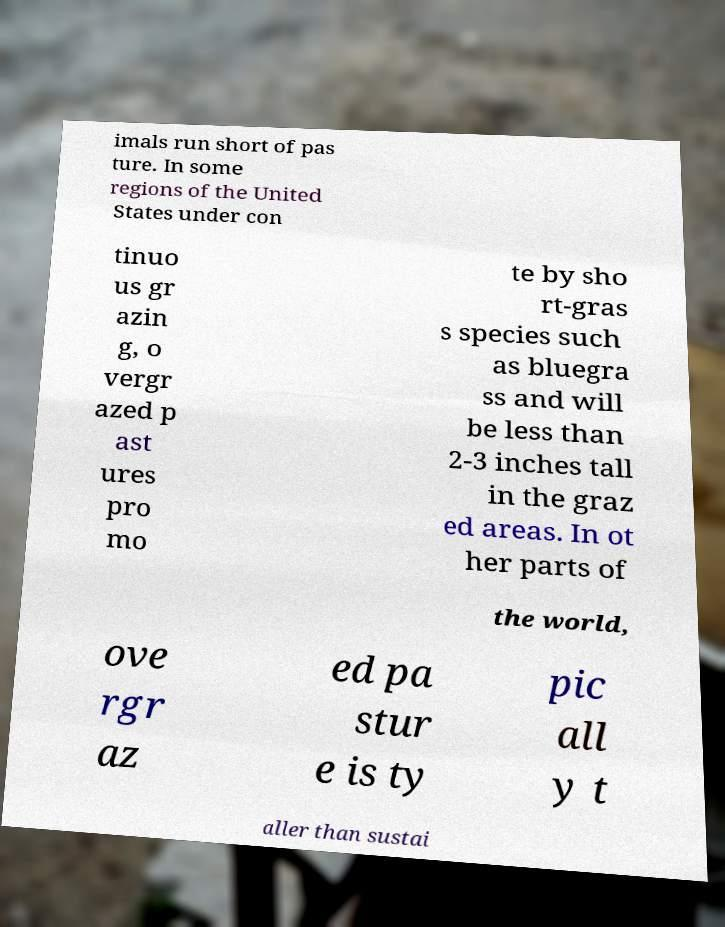For documentation purposes, I need the text within this image transcribed. Could you provide that? imals run short of pas ture. In some regions of the United States under con tinuo us gr azin g, o vergr azed p ast ures pro mo te by sho rt-gras s species such as bluegra ss and will be less than 2-3 inches tall in the graz ed areas. In ot her parts of the world, ove rgr az ed pa stur e is ty pic all y t aller than sustai 